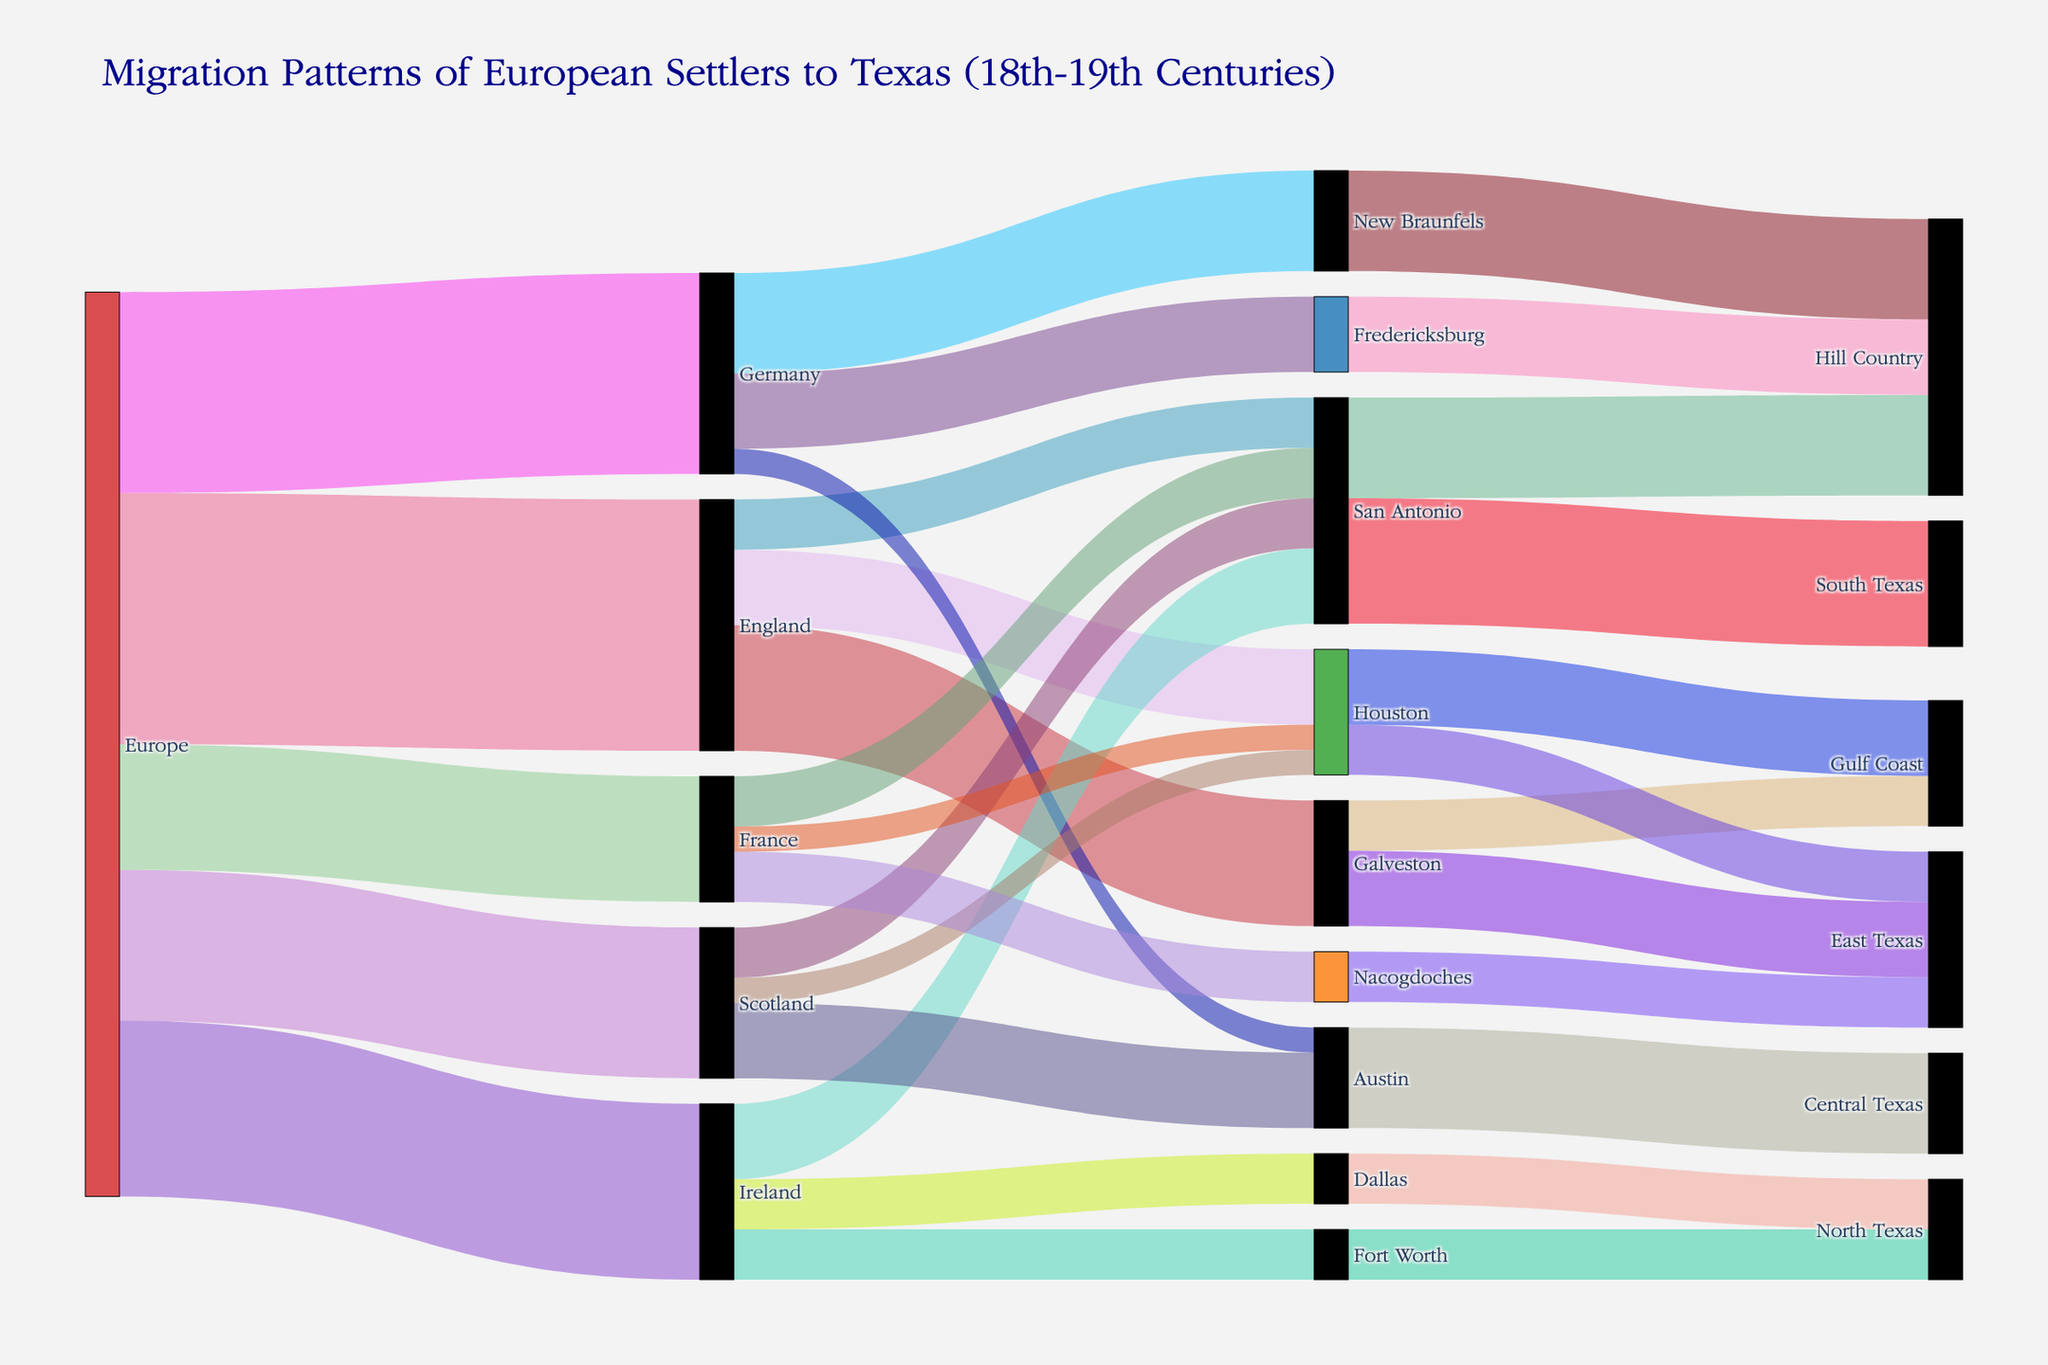Which European country contributed the most settlers to Texas? By observing the thickness of the paths in the Sankey diagram, we see that England has the largest number with 5000 settlers.
Answer: England How many settlers came to San Antonio from European countries? To find the total number of settlers who came to San Antonio from Europe, sum the values of settlers from each country to San Antonio: England (1000), Ireland (1500), Scotland (1000), and France (1000). The total is 1000 + 1500 + 1000 + 1000 = 4500.
Answer: 4500 Which destination in Texas received the most settlers from Europe? Looking at the Sankey diagram, San Antonio receives the most settlers with 4500 settlers coming from Europe (1000 from England + 1500 from Ireland + 1000 from Scotland + 1000 from France).
Answer: San Antonio How many settlers come from Galveston to other parts of Texas? According to the diagram, Galveston sends 1500 settlers to East Texas and 1000 settlers to the Gulf Coast. The total number is 1500 + 1000 = 2500.
Answer: 2500 Which European country sent the fewest settlers to Texas? The smallest contribution from a European country is from France with 2500 settlers.
Answer: France Which region in Texas did most settlers from Germany move to? By observing the paths leading from Germany, the highest value is to New Braunfels with 2000 settlers.
Answer: New Braunfels How many settlers did Scotland send to Houston? According to the diagram, Scotland sent 500 settlers to Houston.
Answer: 500 Compare the number of settlers from Europe to those moving from San Antonio to Hill Country. Which is larger? Europe contributed 18000 settlers to Texas in total. San Antonio contributed 2000 settlers to the Hill Country. Comparing the two, 18000 settlers from Europe is larger than 2000 settlers from San Antonio to the Hill Country.
Answer: From Europe How many settlers migrated to the Hill Country in total? Summing up the values for each link leading to the Hill Country, we get: San Antonio (2000) + New Braunfels (2000) + Fredericksburg (1500). The total is 2000 + 2000 + 1500 = 5500.
Answer: 5500 Which had more settlers, Houston to the Gulf Coast, or Houston to East Texas? Houston sent 1500 settlers to the Gulf Coast and 1000 settlers to East Texas. Therefore, more settlers were sent to the Gulf Coast.
Answer: Gulf Coast 